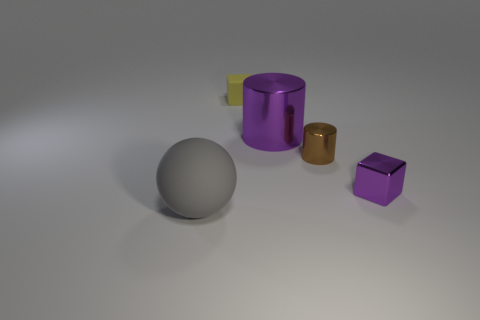Add 3 tiny purple things. How many objects exist? 8 Subtract all brown cylinders. How many cylinders are left? 1 Subtract all green cylinders. How many yellow spheres are left? 0 Subtract all yellow metal cylinders. Subtract all big purple things. How many objects are left? 4 Add 1 tiny metallic cubes. How many tiny metallic cubes are left? 2 Add 2 tiny purple blocks. How many tiny purple blocks exist? 3 Subtract 0 cyan cubes. How many objects are left? 5 Subtract all cubes. How many objects are left? 3 Subtract 1 balls. How many balls are left? 0 Subtract all blue spheres. Subtract all yellow cubes. How many spheres are left? 1 